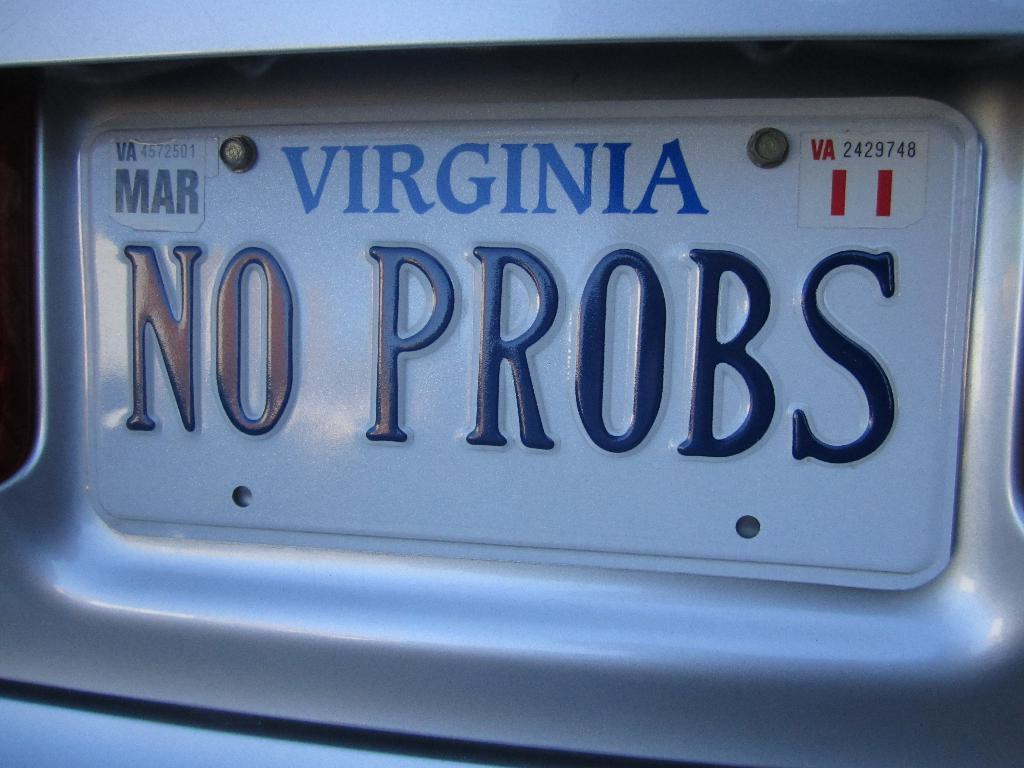<image>
Offer a succinct explanation of the picture presented. a close up of a Virginia license plate NO PROBS 